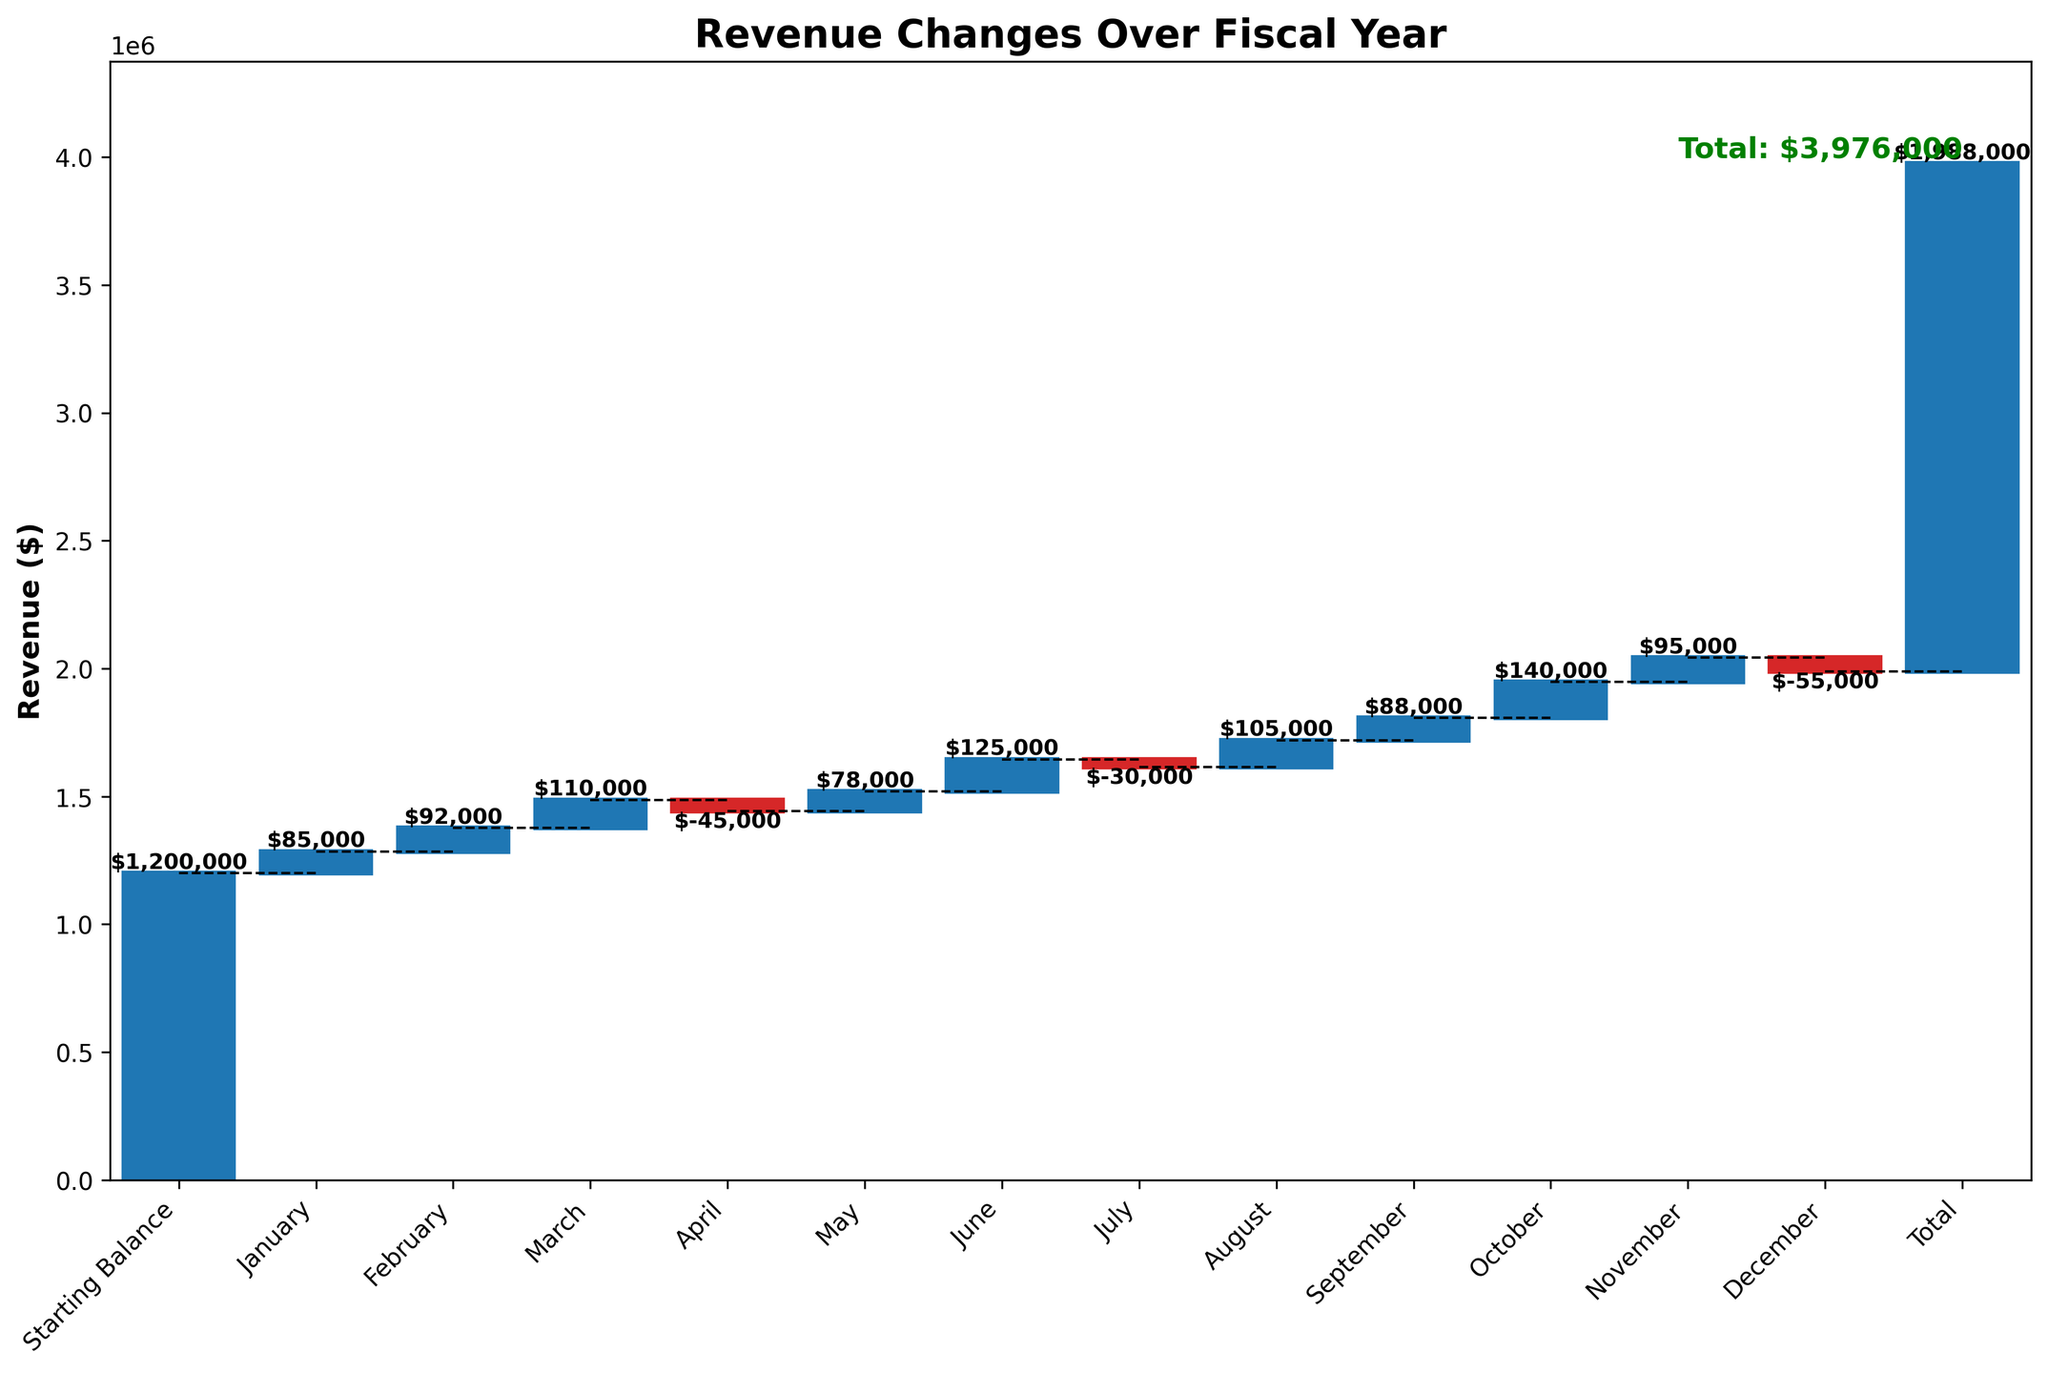What is the title of the chart? The title of the chart is placed at the top of the figure and is usually bolded for emphasis. In this case, the title reads "Revenue Changes Over Fiscal Year."
Answer: Revenue Changes Over Fiscal Year How many months are displayed in the chart? Each bar in the chart represents a month, plus one for the starting balance and one for the total. Counting them in the x-axis labels provides the total count.
Answer: 14 Which month had the highest positive change in revenue? By examining the heights of the positive bars, the tallest one indicates the highest revenue change. October has the tallest positive bar.
Answer: October What is the revenue change in June? Look for the bar labeled June and read the value displayed above it. The bar indicates a positive change of $125,000.
Answer: $125,000 What is the revenue change in April? Examine the bar labeled April, which is a negative bar. It shows the revenue decreased by $45,000.
Answer: -$45,000 What is the cumulative revenue at the end of the fiscal year? The bar labeled "Total" sums all individual changes, resulting in the cumulative revenue. The value displayed is $1,988,000.
Answer: $1,988,000 What months experienced a negative change in revenue? The negative changes are indicated by the red bars. These months are April, July, and December.
Answer: April, July, December How does the revenue change in March compare to that in June? Compare the bar heights and values of March and June. March has an increase of $110,000 while June has an increase of $125,000. June's increase is more significant.
Answer: June had a higher increase What is the net revenue change from January to March? Sum the revenue changes for January, February, and March. That's $85,000 + $92,000 + $110,000 = $287,000.
Answer: $287,000 If you exclude the starting balance, what is the net revenue change solely due to monthly revenue changes? Subtract the starting balance from the total cumulative revenue shown. $1,988,000 - $1,200,000 = $788,000.
Answer: $788,000 